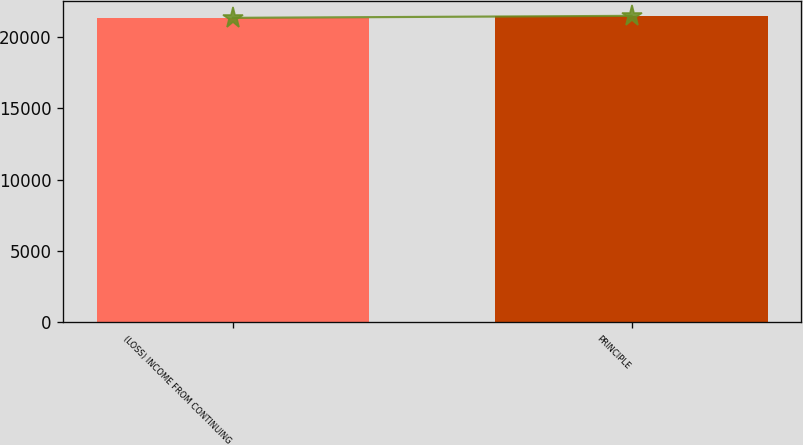<chart> <loc_0><loc_0><loc_500><loc_500><bar_chart><fcel>(LOSS) INCOME FROM CONTINUING<fcel>PRINCIPLE<nl><fcel>21346<fcel>21485.8<nl></chart> 